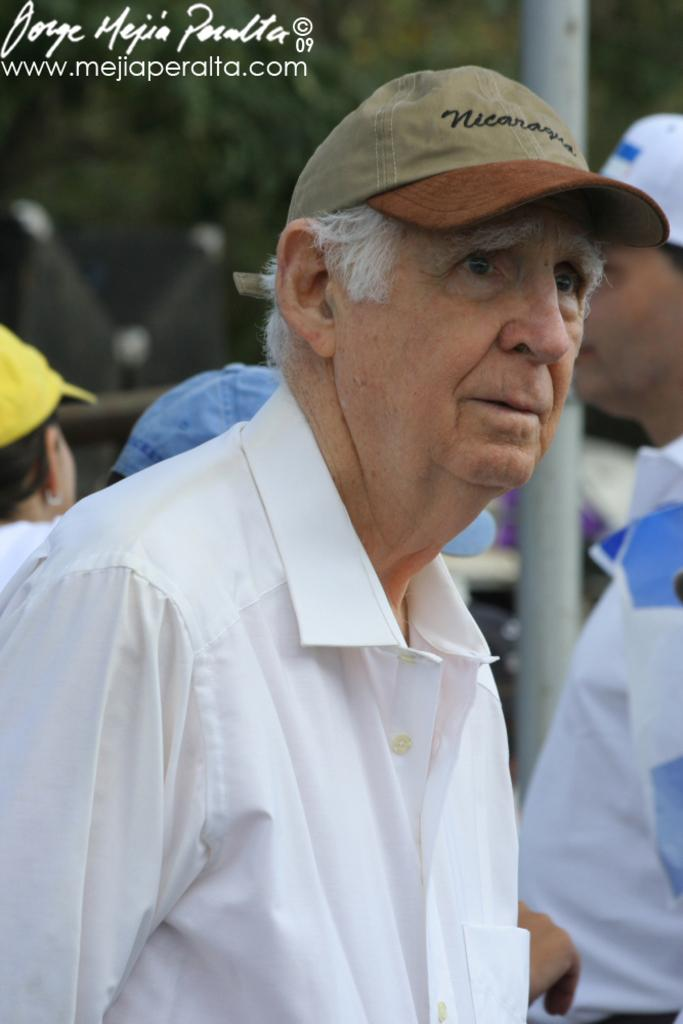How many people are in the image? There is a group of people in the image. What are the people wearing on their heads? The people are wearing caps. What can be seen in the background of the image? There is a pole and trees in the background of the image. Is there any text or logo visible in the image? Yes, there is a watermark in the top left corner of the image. How many legs can be seen on the balloon in the image? There is no balloon present in the image, so it is not possible to determine the number of legs on a balloon. 